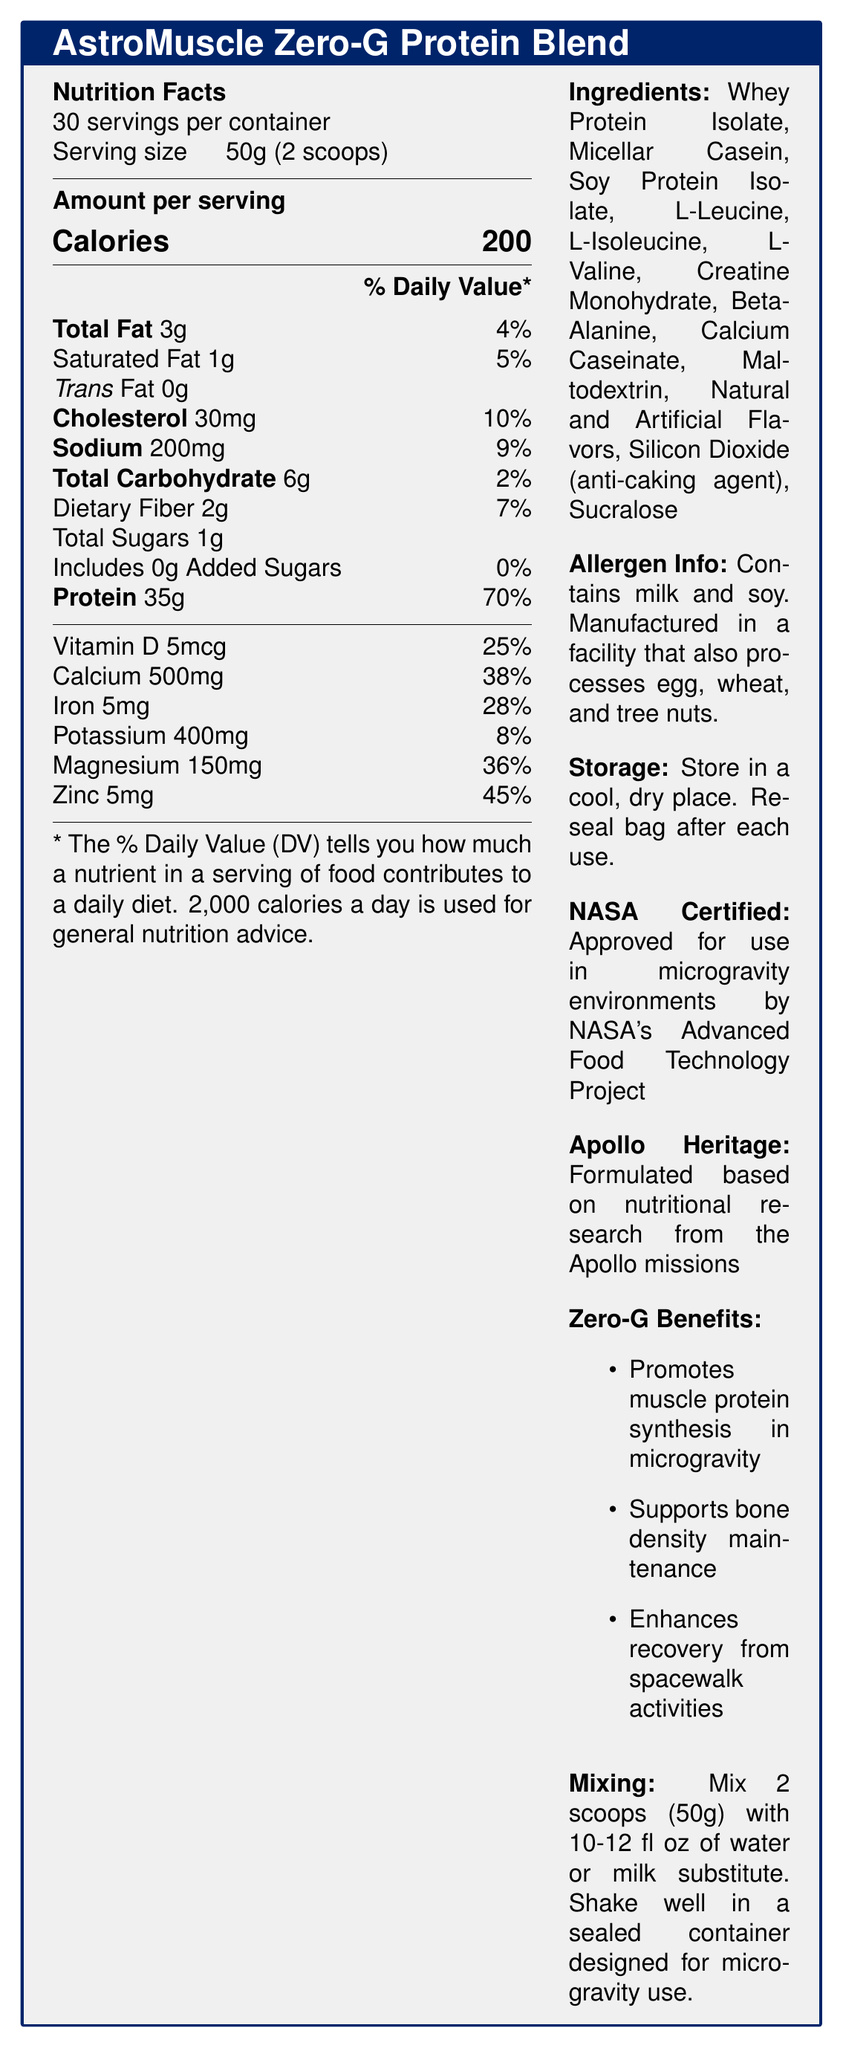What is the serving size of the AstroMuscle Zero-G Protein Blend? The serving size is explicitly listed as "50g (2 scoops)" in the document.
Answer: 50g (2 scoops) How many calories are in one serving of the AstroMuscle Zero-G Protein Blend? The document states that one serving contains 200 calories.
Answer: 200 calories What is the amount of protein per serving, and what percentage of the daily value does it represent? The document indicates that each serving contains 35g of protein, which is 70% of the daily value.
Answer: 35g, 70% Which vitamins and minerals are included in the AstroMuscle Zero-G Protein Blend? The document lists these vitamins and minerals along with their amounts and daily value percentages.
Answer: Vitamin D, Calcium, Iron, Potassium, Magnesium, and Zinc What ingredients might people with food allergies need to be aware of? The allergen information states that the product contains milk and soy.
Answer: Milk and soy What is the daily value percentage of iron in one serving? A. 15% B. 20% C. 28% D. 35% The document lists the daily value of iron as 28%.
Answer: C. 28% Which of the following is *not* an ingredient in the AstroMuscle Zero-G Protein Blend? I. Whey Protein Isolate II. Maltodextrin III. Cocoa Powder IV. Sucralose The document lists all the ingredients, and cocoa powder is not among them.
Answer: III. Cocoa Powder Is the serving size of AstroMuscle Zero-G Protein Blend 100g? The document clearly displays the serving size as 50g (2 scoops).
Answer: No Describe the main features and benefits of AstroMuscle Zero-G Protein Blend. The description summarizes key aspects such as nutritional content, NASA certification, heritage from Apollo missions, and benefits for muscle and bone health in microgravity.
Answer: AstroMuscle Zero-G Protein Blend is a high-protein supplement designed to prevent muscle atrophy in zero-gravity environments. It provides 200 calories, 35g of protein (70% DV), and includes important vitamins and minerals such as Vitamin D, Calcium, Iron, Potassium, Magnesium, and Zinc. It's formulated with ingredients like Whey Protein Isolate, Micellar Casein, and Soy Protein Isolate. The product is NASA-certified for microgravity use and is based on Apollo missions' nutritional research. It promotes muscle protein synthesis, supports bone density, and enhances recovery from spacewalks. What flavors are available for the AstroMuscle Zero-G Protein Blend? The document does not specify the flavor options for the product.
Answer: Not enough information 